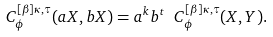<formula> <loc_0><loc_0><loc_500><loc_500>C _ { \phi } ^ { [ \beta ] \kappa , \tau } ( a X , b X ) = a ^ { k } b ^ { t } \ C _ { \phi } ^ { [ \beta ] \kappa , \tau } ( X , Y ) .</formula> 